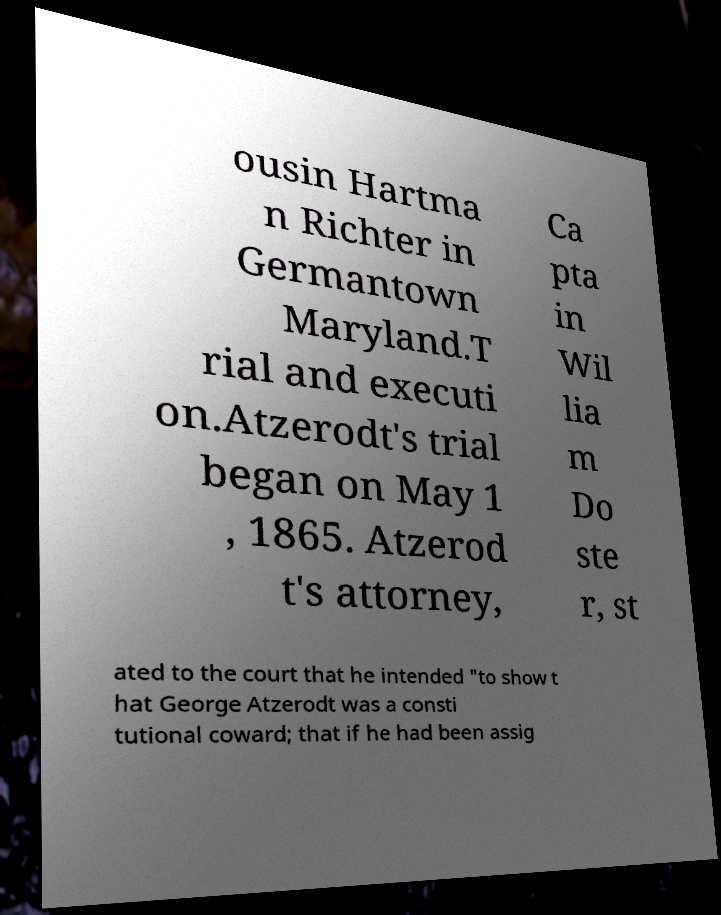Could you assist in decoding the text presented in this image and type it out clearly? ousin Hartma n Richter in Germantown Maryland.T rial and executi on.Atzerodt's trial began on May 1 , 1865. Atzerod t's attorney, Ca pta in Wil lia m Do ste r, st ated to the court that he intended "to show t hat George Atzerodt was a consti tutional coward; that if he had been assig 